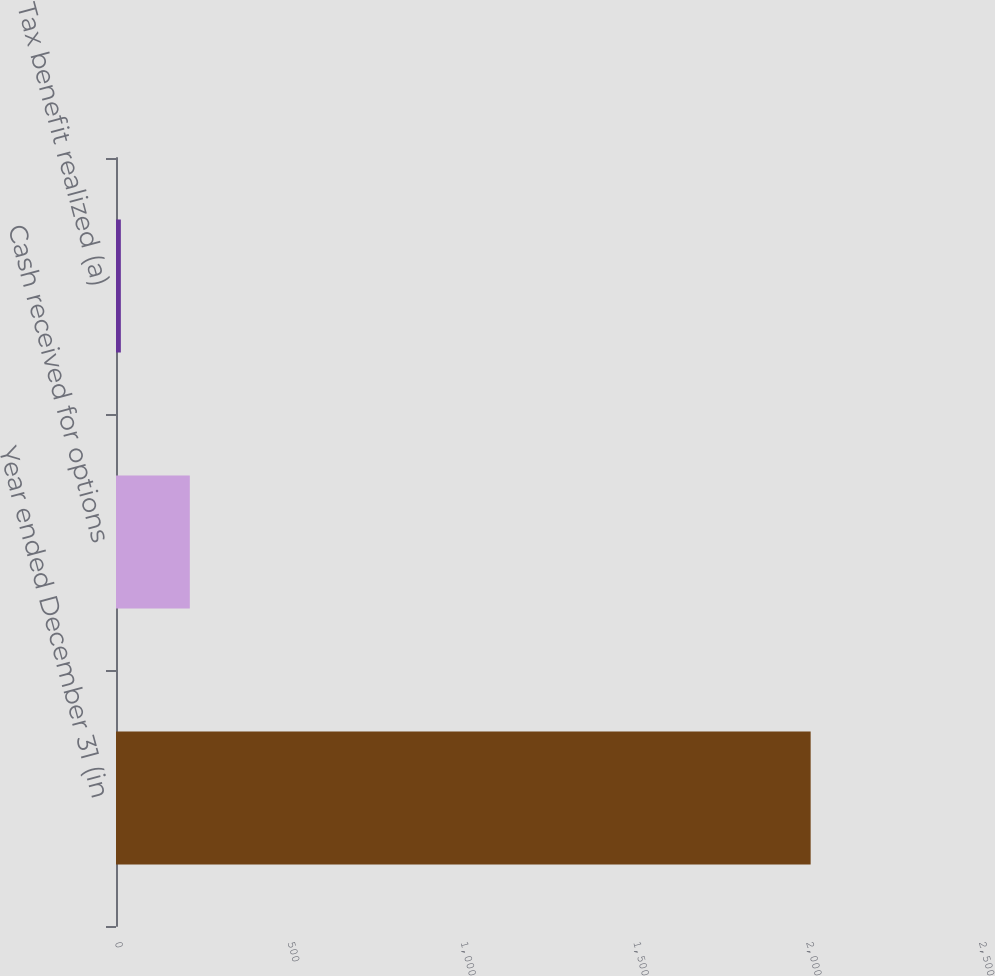Convert chart. <chart><loc_0><loc_0><loc_500><loc_500><bar_chart><fcel>Year ended December 31 (in<fcel>Cash received for options<fcel>Tax benefit realized (a)<nl><fcel>2010<fcel>213.6<fcel>14<nl></chart> 